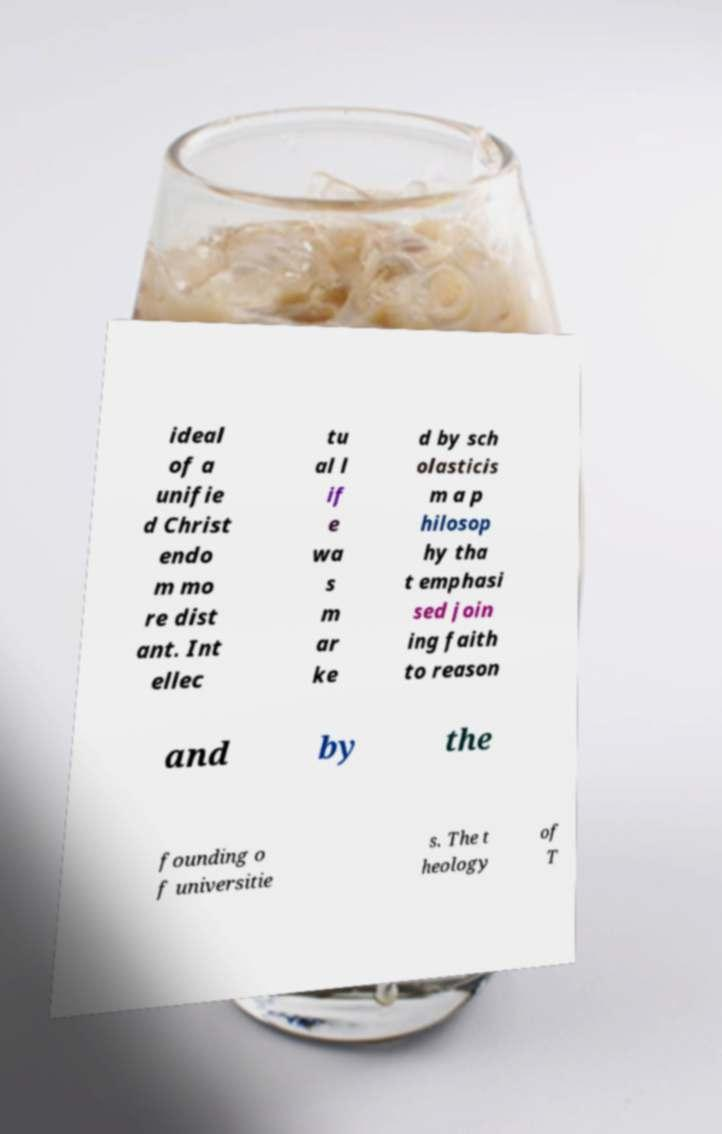What messages or text are displayed in this image? I need them in a readable, typed format. ideal of a unifie d Christ endo m mo re dist ant. Int ellec tu al l if e wa s m ar ke d by sch olasticis m a p hilosop hy tha t emphasi sed join ing faith to reason and by the founding o f universitie s. The t heology of T 